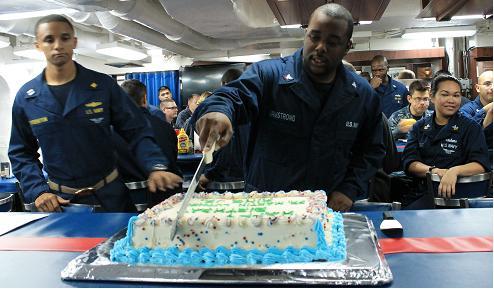What are the people wearing?
Write a very short answer. Uniforms. Are these people at work?
Give a very brief answer. Yes. How many people are cutting the cake?
Keep it brief. 1. 